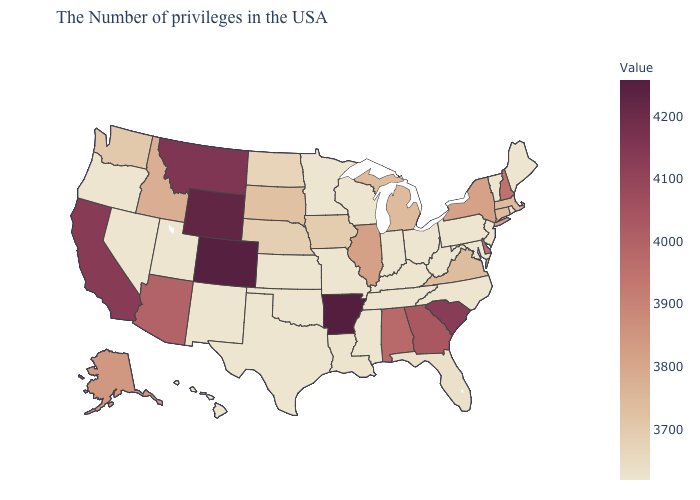Which states have the lowest value in the MidWest?
Short answer required. Ohio, Indiana, Wisconsin, Missouri, Minnesota, Kansas. Among the states that border Arizona , does Utah have the lowest value?
Keep it brief. Yes. 